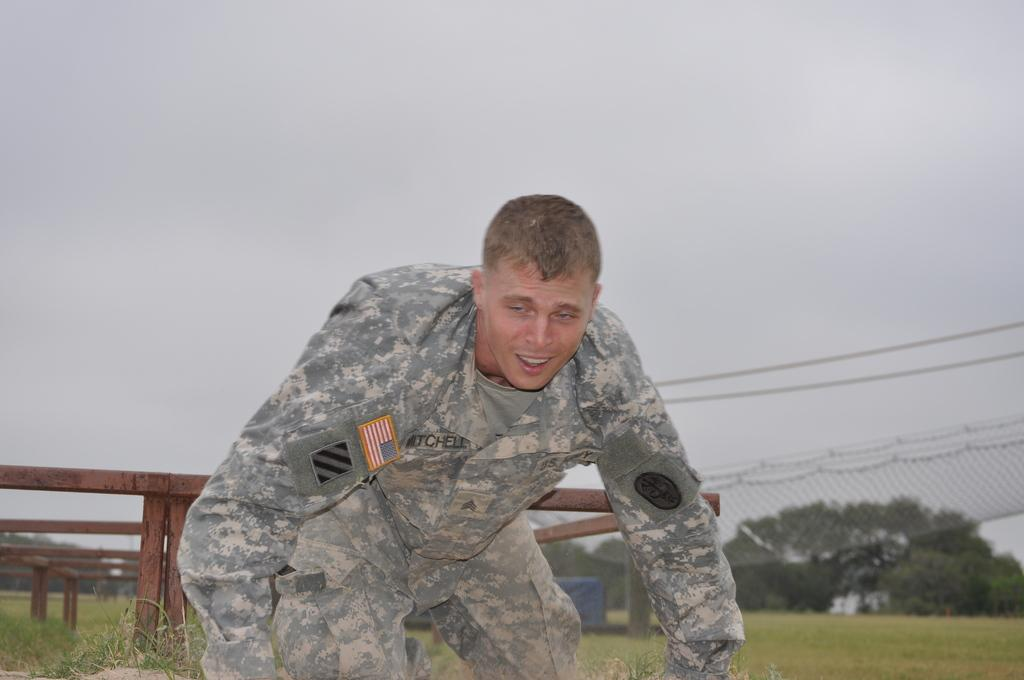Who is the main subject in the image? There is a man in the middle of the image. What is behind the man in the image? There is wooden railing behind the man. What can be seen in the distance in the image? There are trees in the background of the image. What is visible above the trees in the image? The sky is visible in the background of the image. What type of rake is the man using in the image? There is no rake present in the image; the man is not performing any activity involving a rake. 